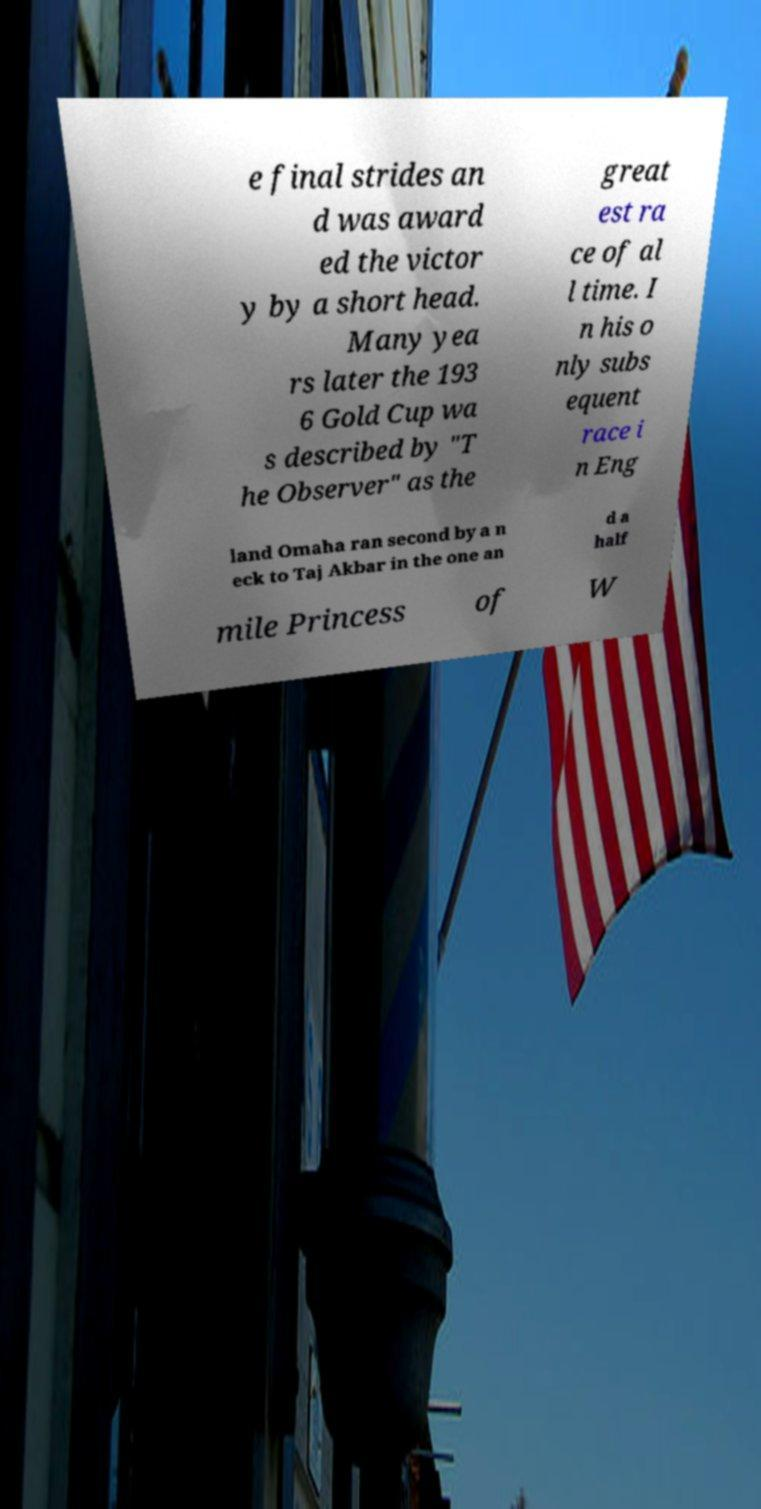What messages or text are displayed in this image? I need them in a readable, typed format. e final strides an d was award ed the victor y by a short head. Many yea rs later the 193 6 Gold Cup wa s described by "T he Observer" as the great est ra ce of al l time. I n his o nly subs equent race i n Eng land Omaha ran second by a n eck to Taj Akbar in the one an d a half mile Princess of W 